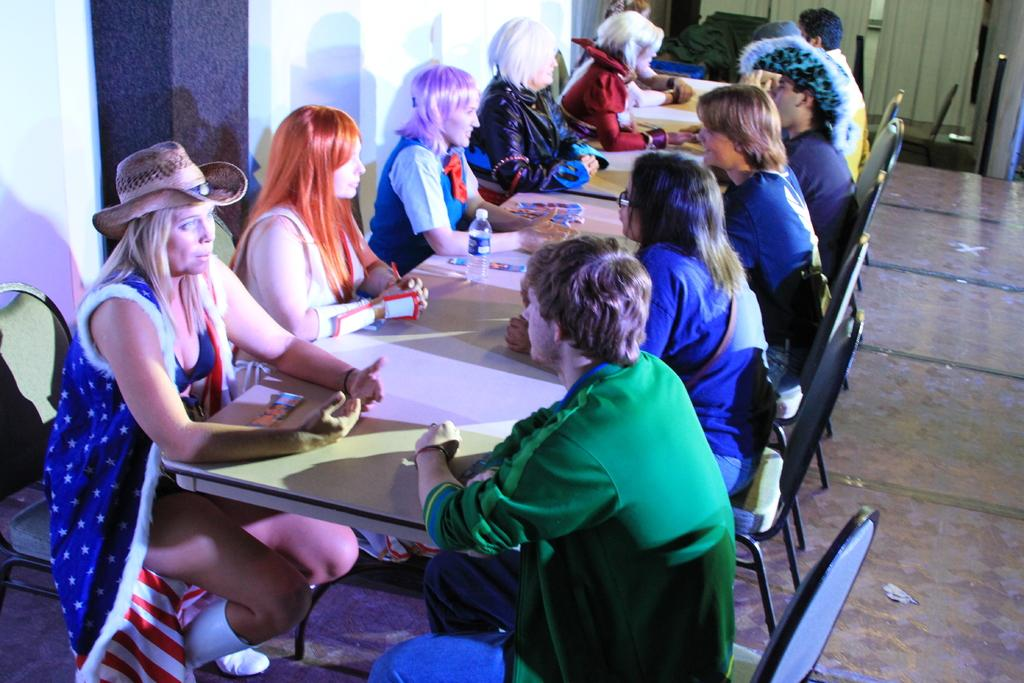What are the people in the image doing? The people in the image are sitting on chairs. Where are the people sitting in relation to the tables? The people are sitting in front of the tables. What can be seen on the tables in the image? There are bottles on the tables. What else is placed on the tables besides the bottles? There is something placed on the tables, but the specific item is not mentioned in the facts. What type of geese can be seen flying over the people in the image? There are no geese present in the image; it only features people sitting on chairs in front of tables. 